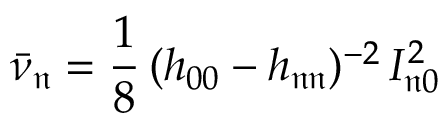<formula> <loc_0><loc_0><loc_500><loc_500>\bar { \nu } _ { \mathfrak { n } } = \frac { 1 } { 8 } \, ( h _ { 0 0 } - h _ { \mathfrak { n } \mathfrak { n } } ) ^ { - 2 } \, I _ { \mathfrak { n } 0 } ^ { 2 }</formula> 